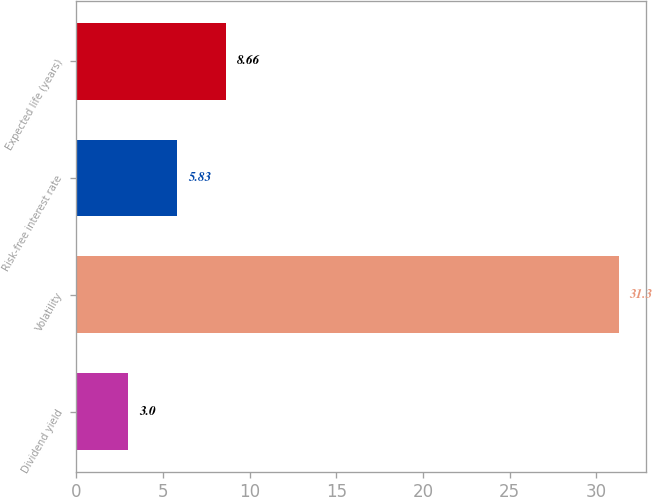Convert chart to OTSL. <chart><loc_0><loc_0><loc_500><loc_500><bar_chart><fcel>Dividend yield<fcel>Volatility<fcel>Risk-free interest rate<fcel>Expected life (years)<nl><fcel>3<fcel>31.3<fcel>5.83<fcel>8.66<nl></chart> 